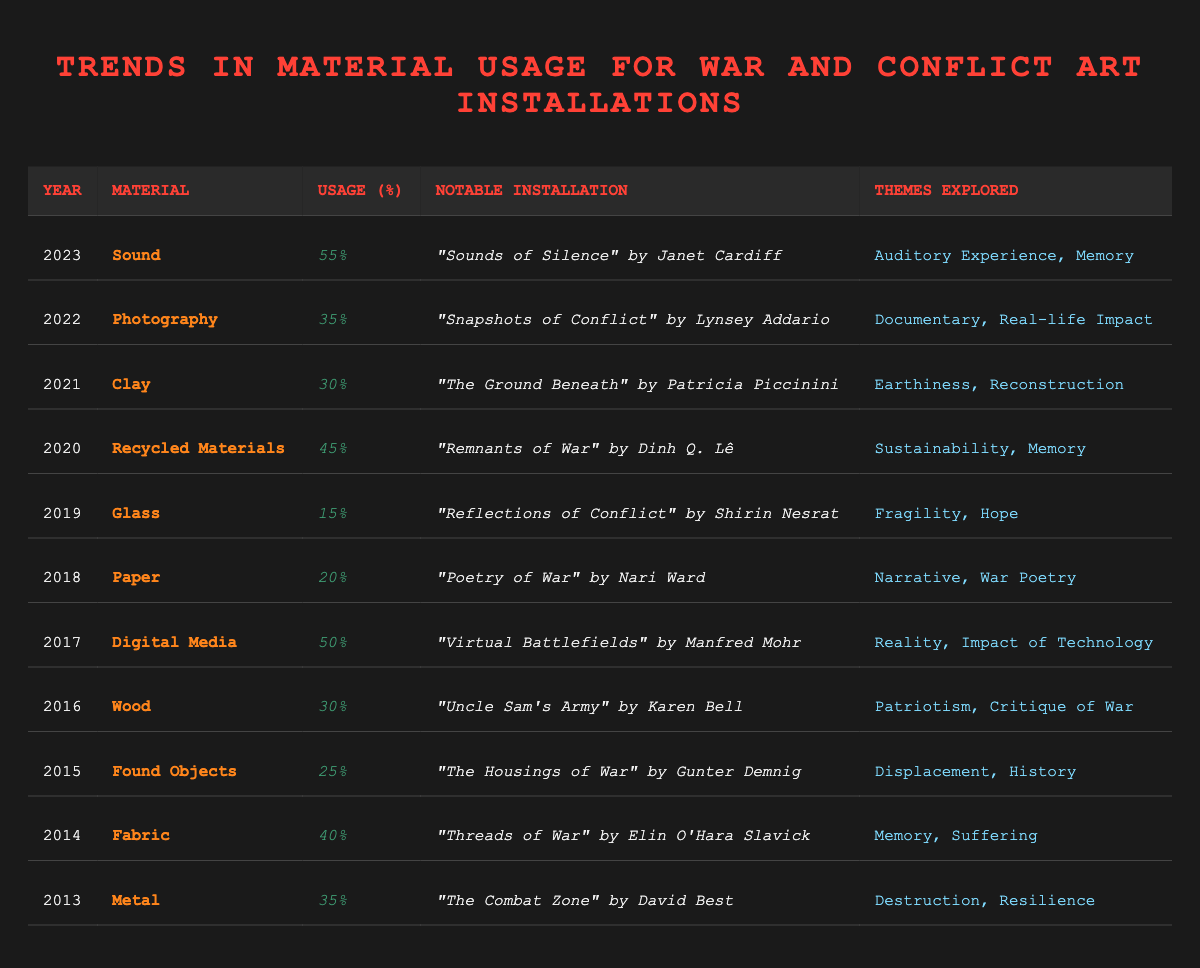What was the percentage usage of Digital Media in 2017? The table shows that in 2017, the percentage usage of Digital Media was 50%.
Answer: 50% Which material had the lowest percentage usage in 2019? According to the table, in 2019, the material with the lowest percentage usage was Glass at 15%.
Answer: Glass What are the themes explored in the installation "Threads of War" by Elin O'Hara Slavick? The table indicates that the themes explored in "Threads of War" are Memory and Suffering.
Answer: Memory, Suffering How much did the usage of Recycled Materials increase from 2019 to 2020? In 2019, the usage of Glass was 15%, while in 2020, Recycled Materials had a usage of 45%. The increase is calculated as 45% - 15% = 30%.
Answer: 30% Which year saw a higher reliance on Fabric versus Metal materials? The table indicates that Fabric had a percentage usage of 40% in 2014, while Metal had a usage of 35% in 2013. Therefore, 2014 saw a higher reliance on Fabric compared to Metal.
Answer: 2014 Did any installation highlight the theme of sustainability? Yes, the installation "Remnants of War" by Dinh Q. Lê, which used Recycled Materials in 2020, emphasized the theme of Sustainability.
Answer: Yes What is the average percentage usage of materials for art installations addressing war and conflict from 2013 to 2016? The percentage usage for the years 2013 (35%), 2014 (40%), 2015 (25%), and 2016 (30%) adds up to 130%. Dividing by 4 (the number of years) gives an average of 32.5%.
Answer: 32.5% Which installation dealt with themes of fragility and hope? The table states that "Reflections of Conflict" by Shirin Nesrat explored themes of Fragility and Hope in 2019.
Answer: Reflections of Conflict Which material was used most in installations from 2013 to 2016? Based on the table, the material with the highest usage percentage in that period is Fabric at 40% (2014). If we look at each year's percentages, none exceed this.
Answer: Fabric 